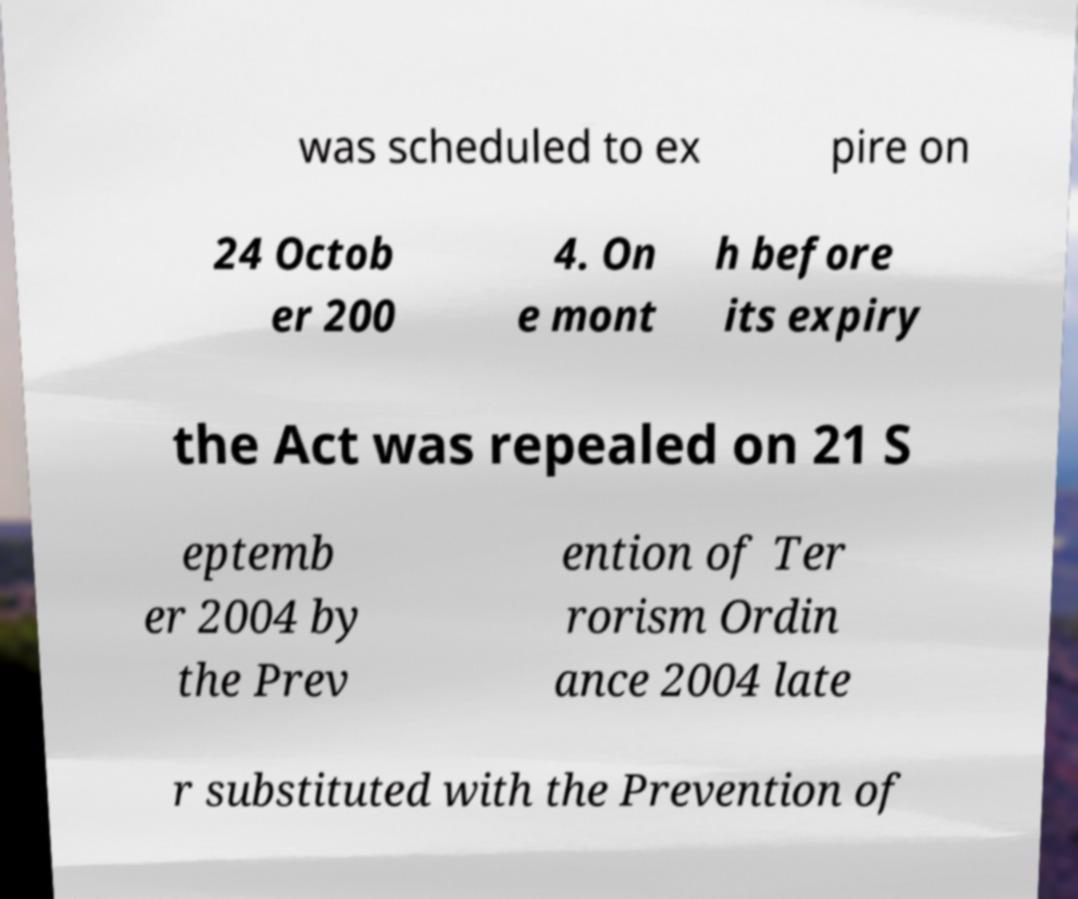There's text embedded in this image that I need extracted. Can you transcribe it verbatim? was scheduled to ex pire on 24 Octob er 200 4. On e mont h before its expiry the Act was repealed on 21 S eptemb er 2004 by the Prev ention of Ter rorism Ordin ance 2004 late r substituted with the Prevention of 